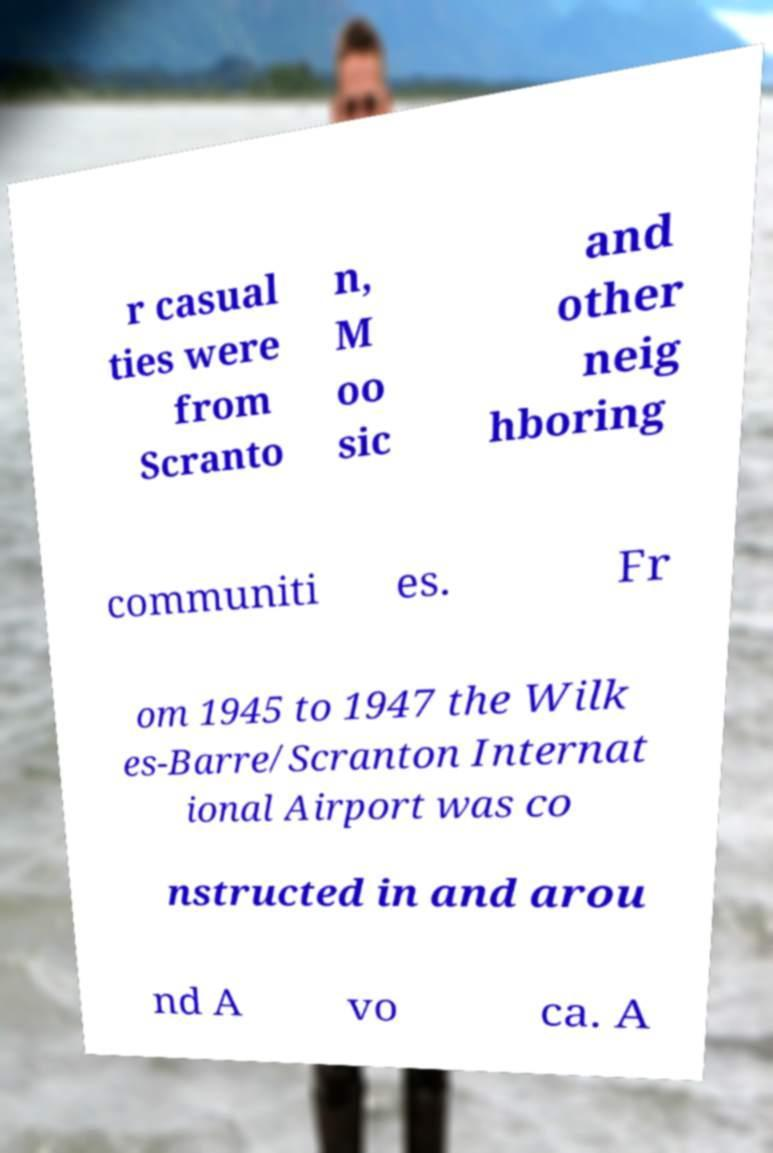I need the written content from this picture converted into text. Can you do that? r casual ties were from Scranto n, M oo sic and other neig hboring communiti es. Fr om 1945 to 1947 the Wilk es-Barre/Scranton Internat ional Airport was co nstructed in and arou nd A vo ca. A 